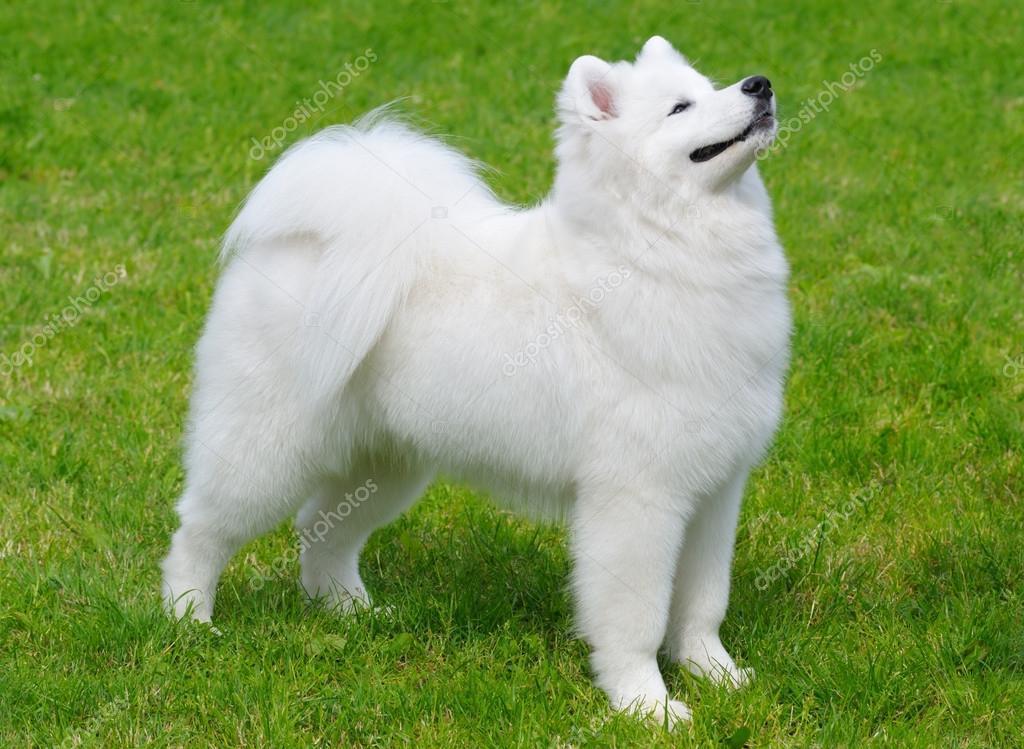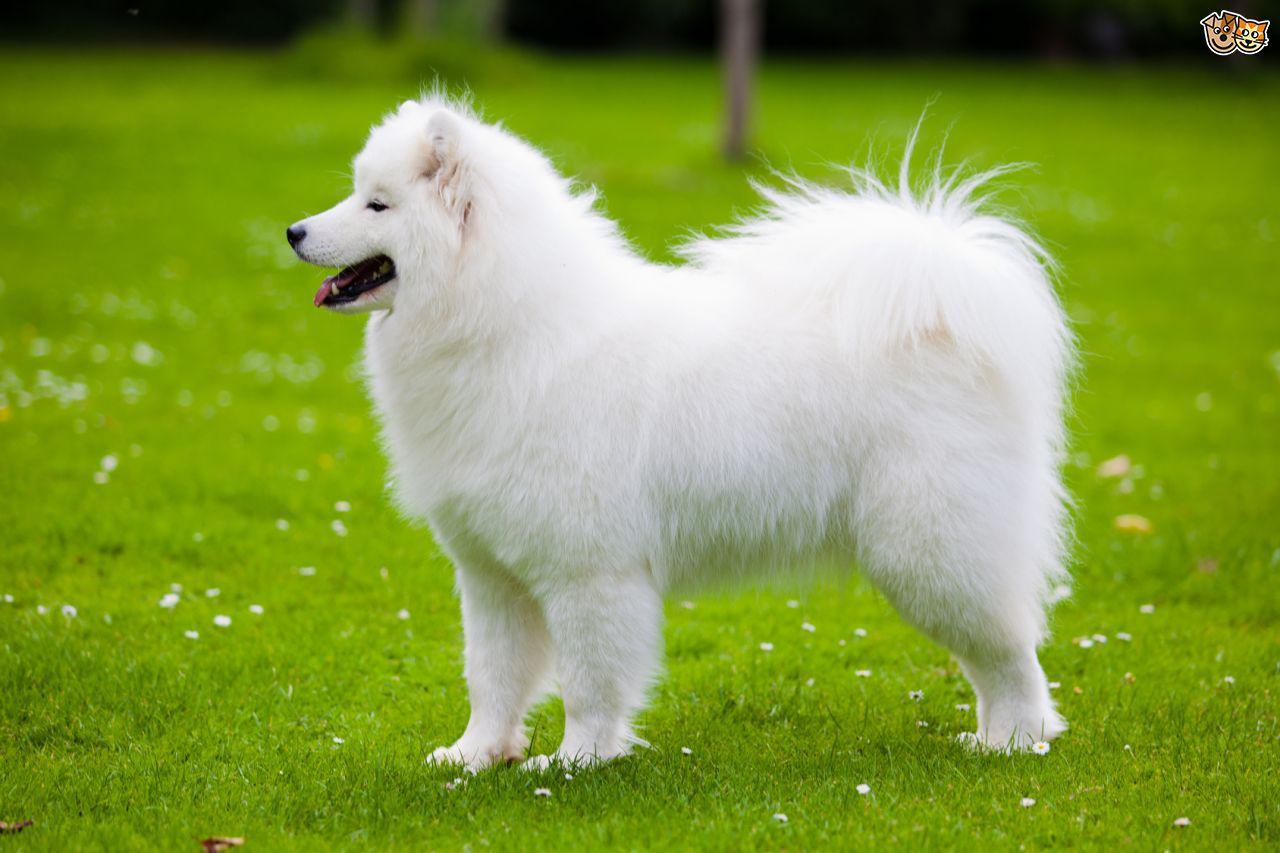The first image is the image on the left, the second image is the image on the right. Analyze the images presented: Is the assertion "The dogs appear to be facing each other." valid? Answer yes or no. Yes. 